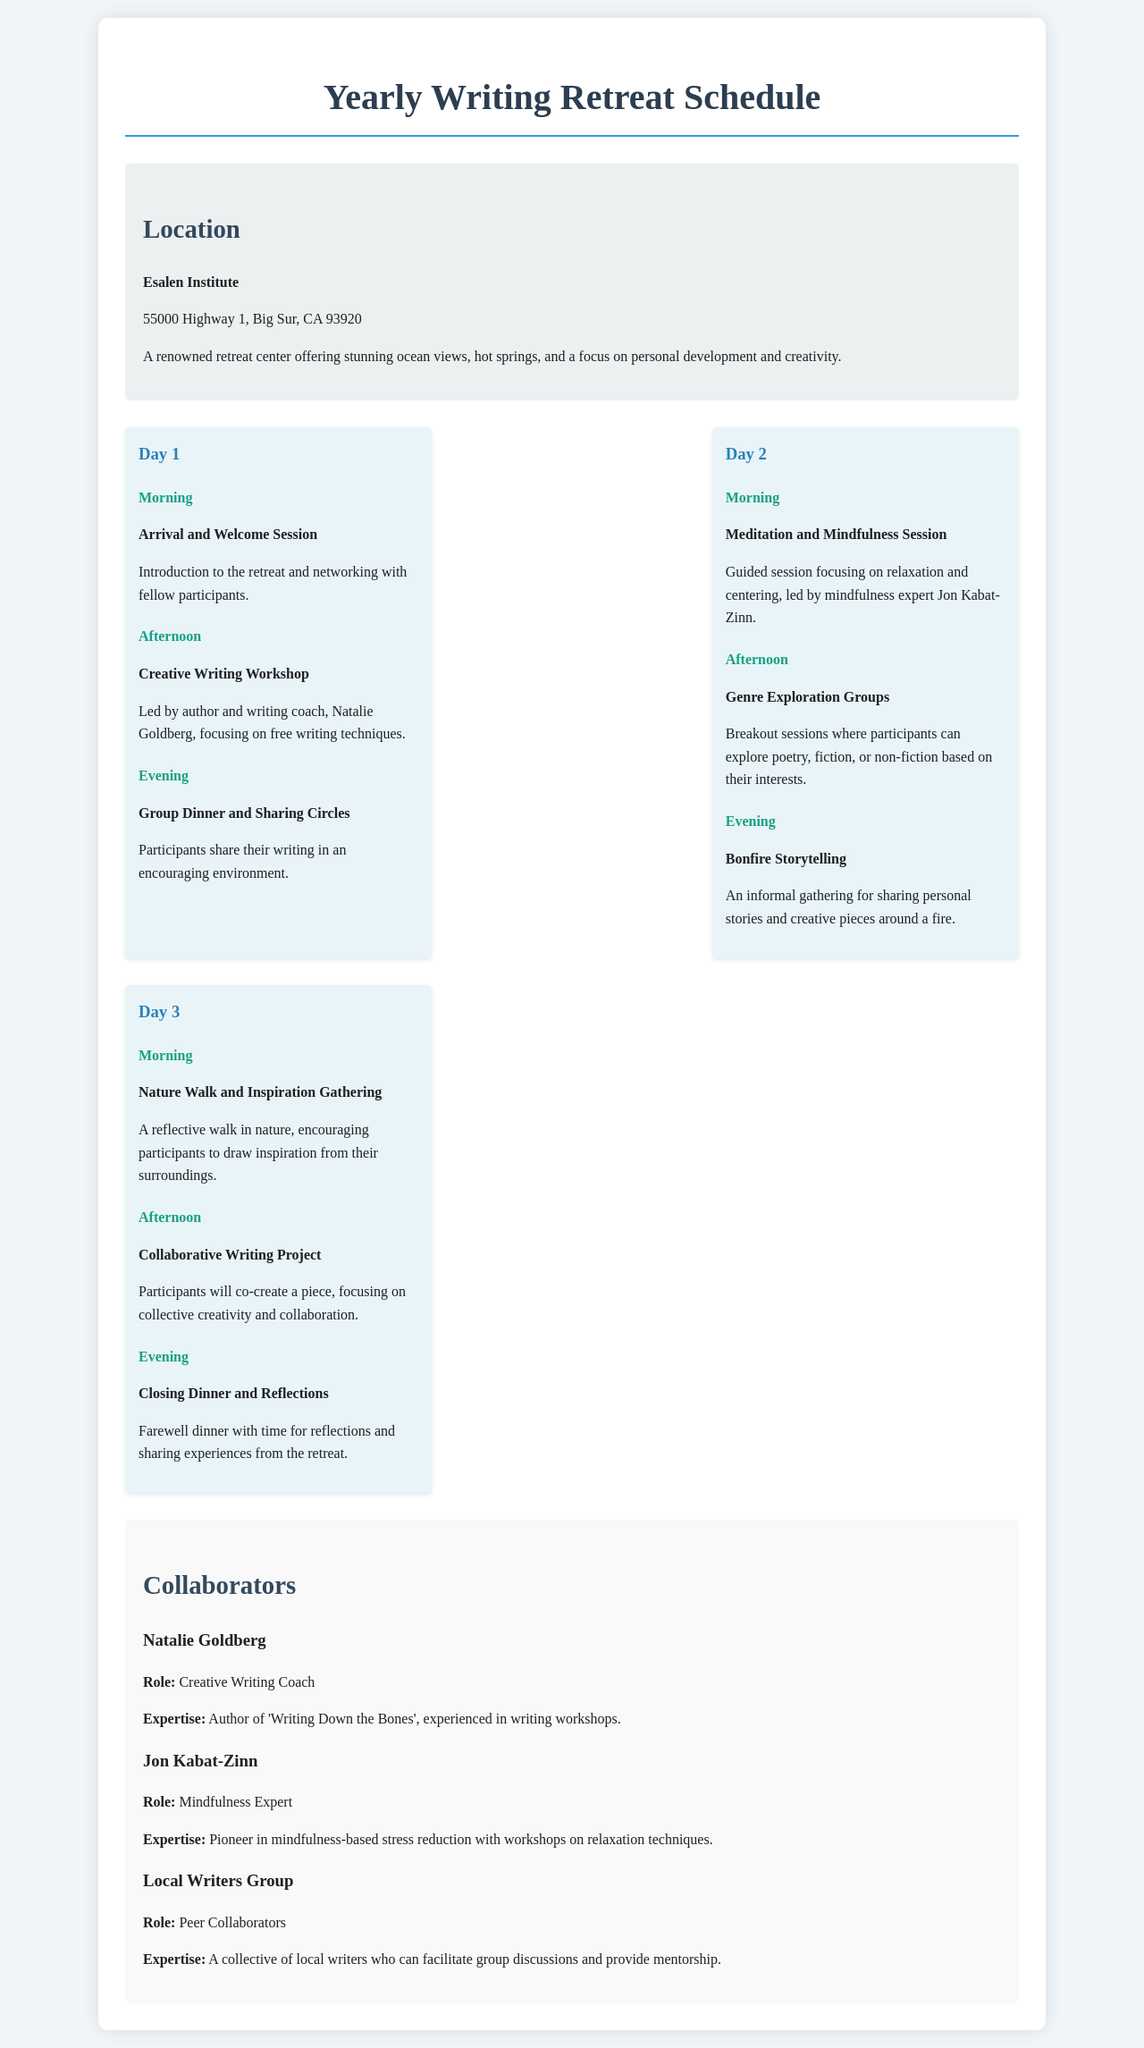What is the location of the retreat? The document specifies that the retreat will be held at the Esalen Institute in Big Sur, California.
Answer: Esalen Institute Who is leading the Creative Writing Workshop? The document mentions Natalie Goldberg as the facilitator for this workshop.
Answer: Natalie Goldberg How many days does the retreat last? The schedule outlines activities for three distinct days, indicating the total duration.
Answer: 3 What time of day does the Bonfire Storytelling occur? The document categorizes the Bonfire Storytelling event under the evening activities of Day 2.
Answer: Evening What type of session is scheduled for the morning of Day 2? The document specifies that a Meditation and Mindfulness Session is scheduled for that time slot.
Answer: Meditation and Mindfulness Session What activity involves participants sharing their writing? The document refers to the Group Dinner and Sharing Circles as the event where writing is shared among participants.
Answer: Group Dinner and Sharing Circles Who is recognized for expertise in mindfulness? The document identifies Jon Kabat-Zinn as the mindfulness expert for the retreat.
Answer: Jon Kabat-Zinn What is the purpose of the Nature Walk on Day 3? The document mentions that the Nature Walk serves to encourage participants to draw inspiration from their surroundings.
Answer: Inspiration Gathering 